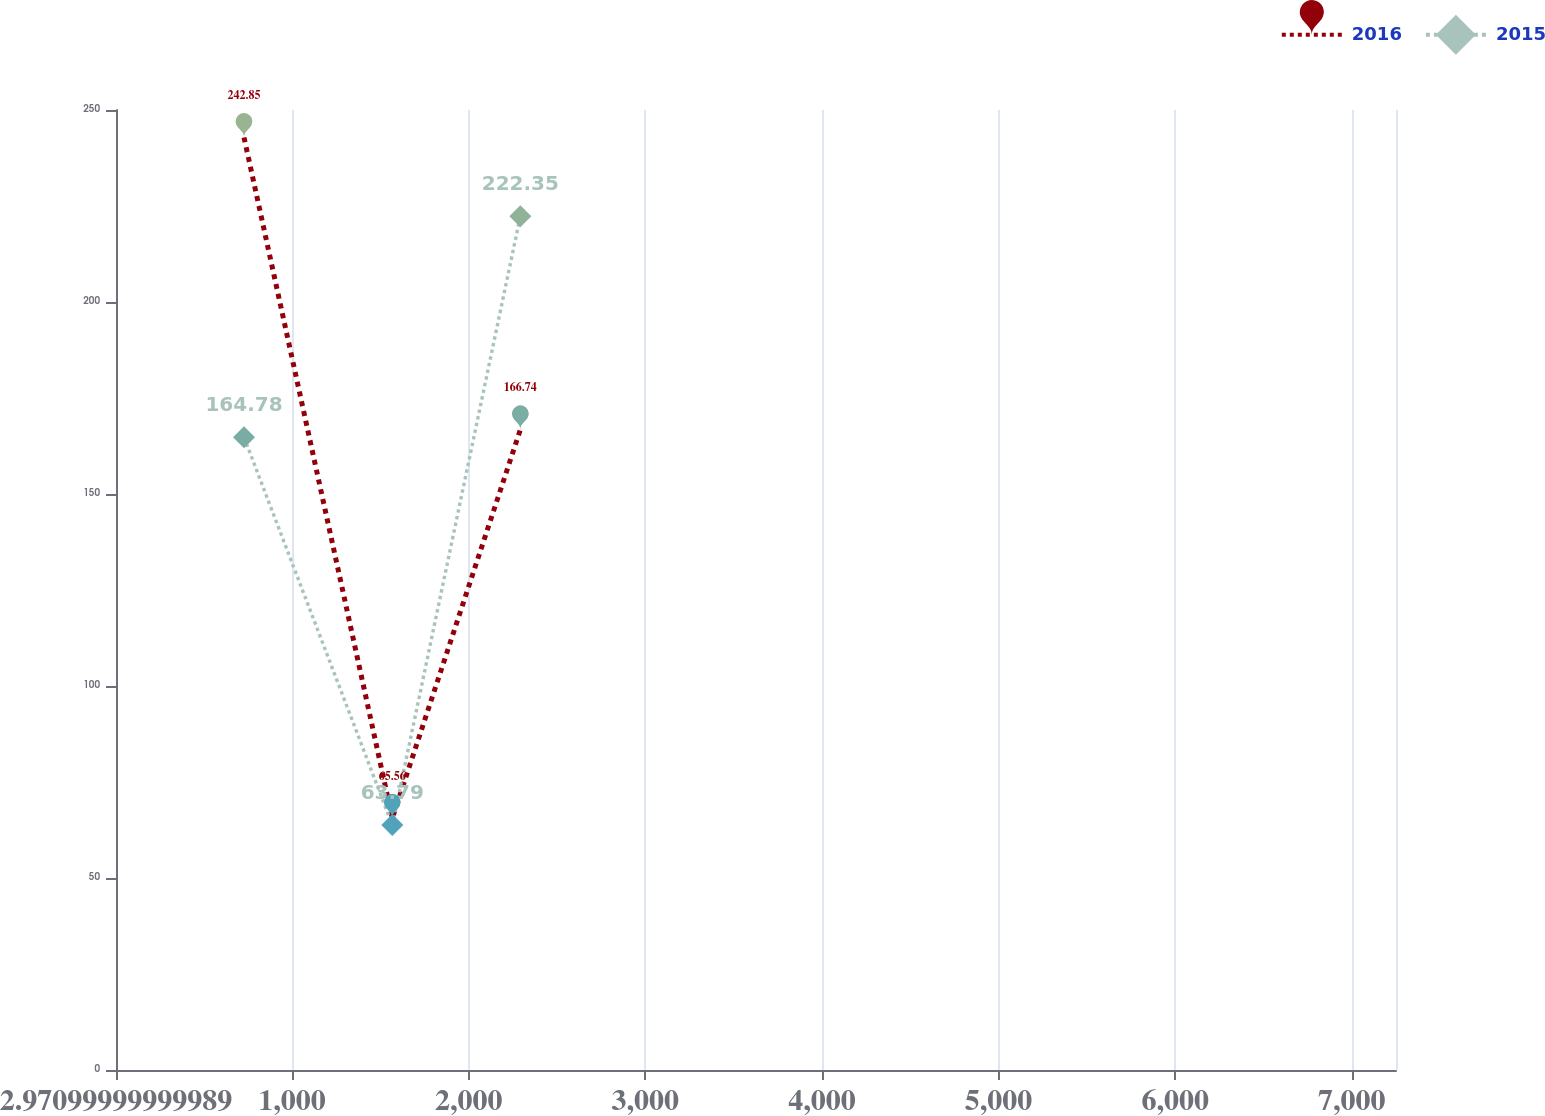Convert chart. <chart><loc_0><loc_0><loc_500><loc_500><line_chart><ecel><fcel>2016<fcel>2015<nl><fcel>727.67<fcel>242.85<fcel>164.78<nl><fcel>1567.41<fcel>65.56<fcel>63.79<nl><fcel>2292.11<fcel>166.74<fcel>222.35<nl><fcel>7974.66<fcel>826.63<fcel>639.49<nl></chart> 